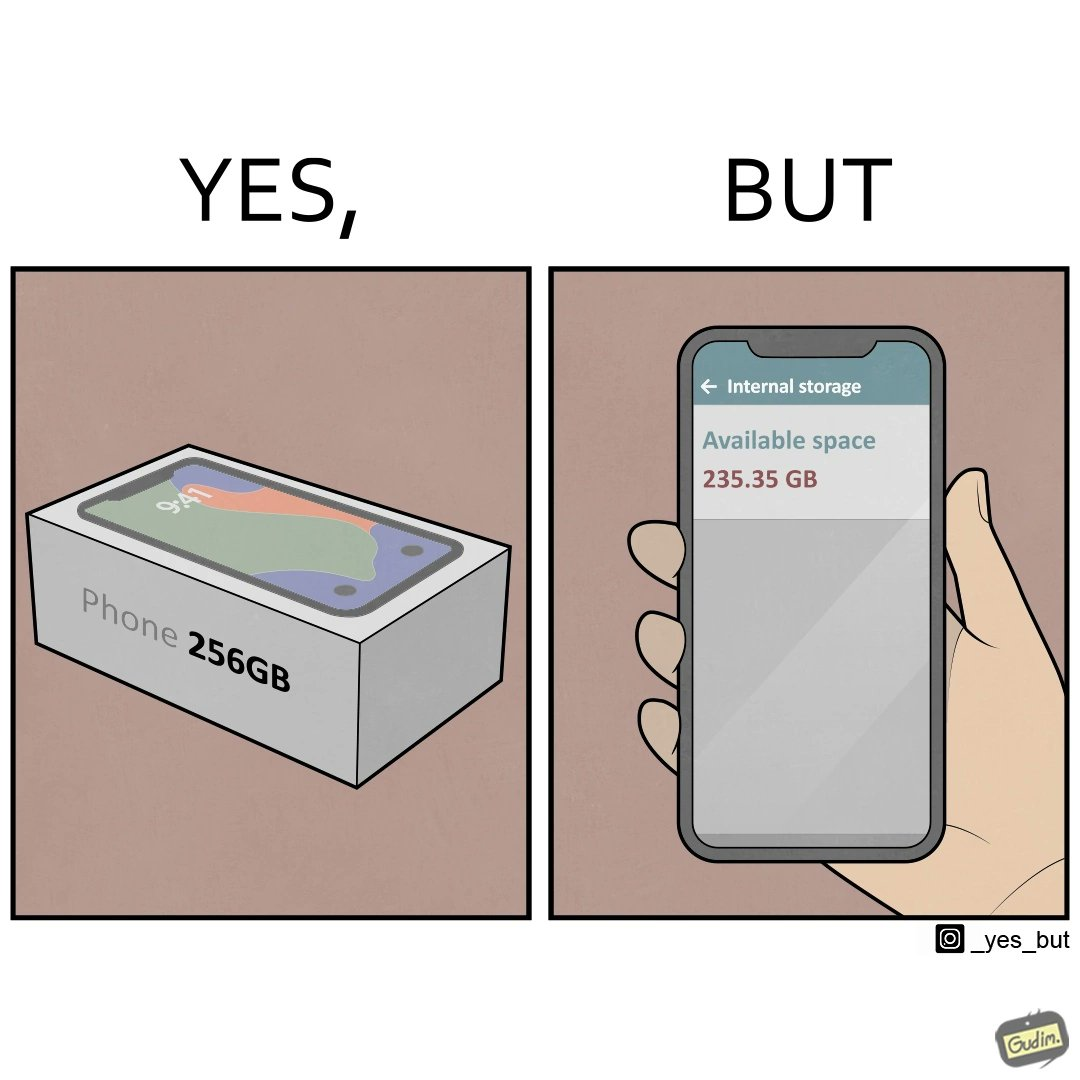Describe the contrast between the left and right parts of this image. In the left part of the image: It is a smartphone box claiming the phone has a storage capacity of 256 gb In the right part of the image: It is a smartphone with 235.35 gb of available space 